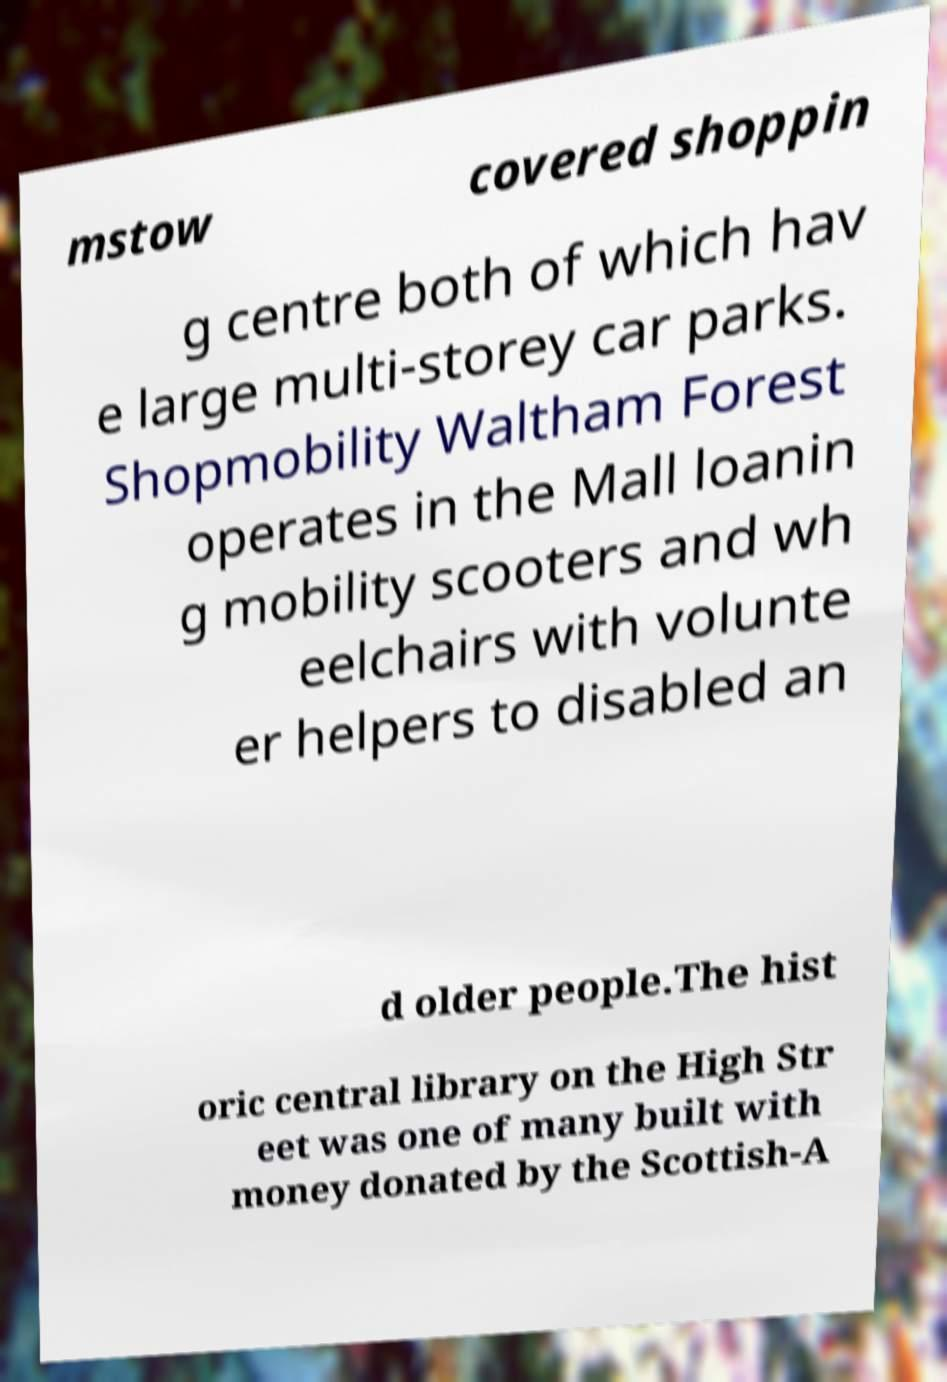Could you extract and type out the text from this image? mstow covered shoppin g centre both of which hav e large multi-storey car parks. Shopmobility Waltham Forest operates in the Mall loanin g mobility scooters and wh eelchairs with volunte er helpers to disabled an d older people.The hist oric central library on the High Str eet was one of many built with money donated by the Scottish-A 